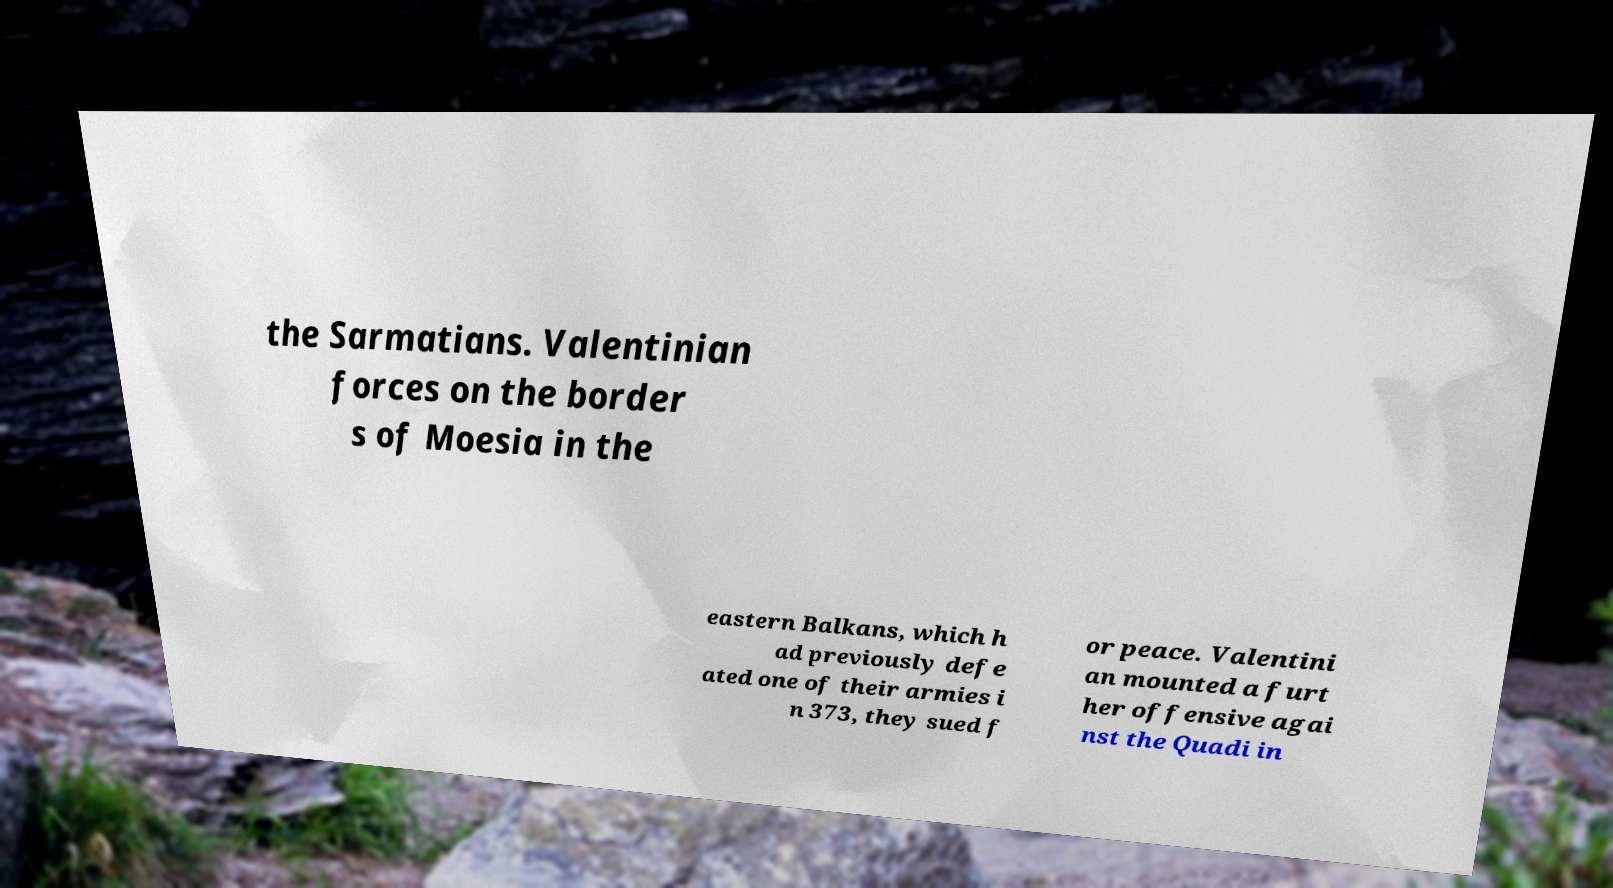What messages or text are displayed in this image? I need them in a readable, typed format. the Sarmatians. Valentinian forces on the border s of Moesia in the eastern Balkans, which h ad previously defe ated one of their armies i n 373, they sued f or peace. Valentini an mounted a furt her offensive agai nst the Quadi in 